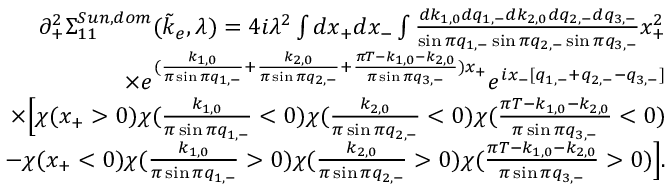Convert formula to latex. <formula><loc_0><loc_0><loc_500><loc_500>\begin{array} { r l r } & { \partial _ { + } ^ { 2 } \Sigma _ { 1 1 } ^ { S u n , d o m } ( \tilde { k } _ { e } , \lambda ) = 4 i \lambda ^ { 2 } \int d x _ { + } d x _ { - } \int \frac { d k _ { 1 , 0 } d q _ { 1 , - } d k _ { 2 , 0 } d q _ { 2 , - } d q _ { 3 , - } } { \sin \pi q _ { 1 , - } \sin \pi q _ { 2 , - } \sin \pi q _ { 3 , - } } x _ { + } ^ { 2 } } \\ & { \quad \times e ^ { ( \frac { k _ { 1 , 0 } } { \pi \sin \pi q _ { 1 , - } } + \frac { k _ { 2 , 0 } } { \pi \sin \pi q _ { 2 , - } } + \frac { \pi T - k _ { 1 , 0 } - k _ { 2 , 0 } } { \pi \sin \pi q _ { 3 , - } } ) x _ { + } } e ^ { i x _ { - } [ q _ { 1 , - } + q _ { 2 , - } - q _ { 3 , - } ] } } \\ & { \quad \times \left [ \chi ( x _ { + } > 0 ) \chi ( \frac { k _ { 1 , 0 } } { \pi \sin \pi q _ { 1 , - } } < 0 ) \chi ( \frac { k _ { 2 , 0 } } { \pi \sin \pi q _ { 2 , - } } < 0 ) \chi ( \frac { \pi T - k _ { 1 , 0 } - k _ { 2 , 0 } } { \pi \sin \pi q _ { 3 , - } } < 0 ) } \\ & { \quad - \chi ( x _ { + } < 0 ) \chi ( \frac { k _ { 1 , 0 } } { \pi \sin \pi q _ { 1 , - } } > 0 ) \chi ( \frac { k _ { 2 , 0 } } { \pi \sin \pi q _ { 2 , - } } > 0 ) \chi ( \frac { \pi T - k _ { 1 , 0 } - k _ { 2 , 0 } } { \pi \sin \pi q _ { 3 , - } } > 0 ) \right ] . } \end{array}</formula> 